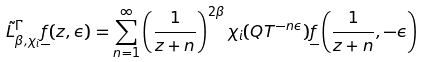Convert formula to latex. <formula><loc_0><loc_0><loc_500><loc_500>\tilde { L } _ { \beta , \chi _ { i } } ^ { \Gamma } \underline { f } ( z , \epsilon ) = \sum _ { n = 1 } ^ { \infty } \left ( \frac { 1 } { z + n } \right ) ^ { 2 \beta } \chi _ { i } ( Q T ^ { - n \epsilon } ) \underline { f } \left ( \frac { 1 } { z + n } , - \epsilon \right )</formula> 